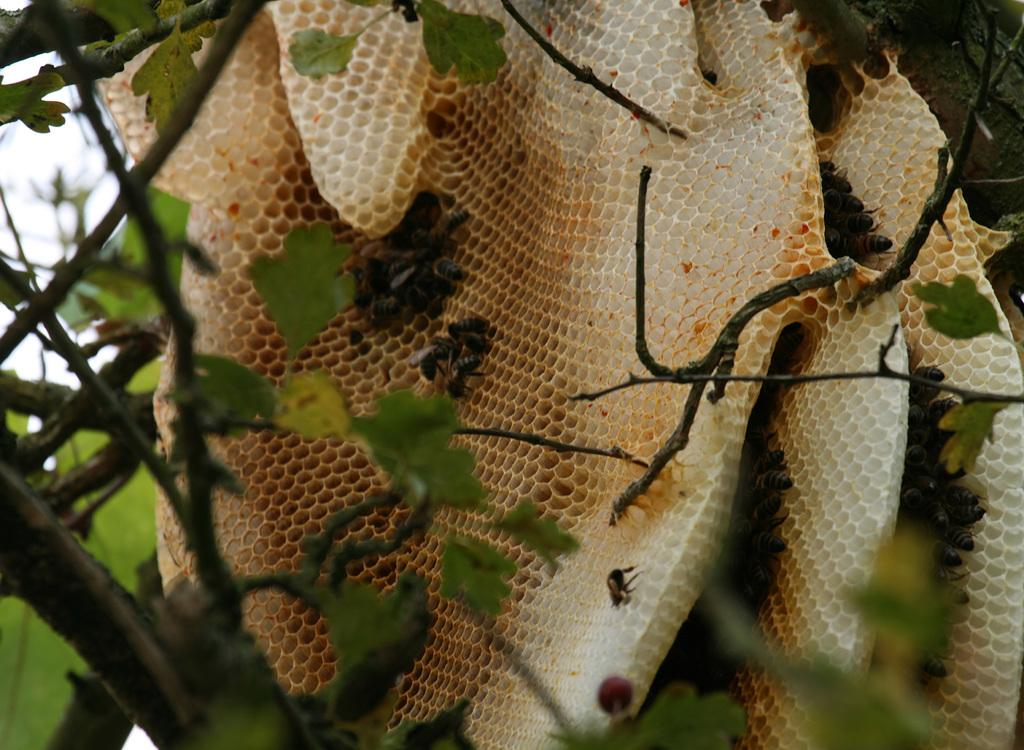What type of structures can be seen in the image? There are beehives in the image. What natural elements are present in the image? There are trees in the image. What type of insects can be seen in the image? Honey bees are present in the image. What type of calendar can be seen hanging from the tree in the image? There is no calendar present in the image; it features beehives, trees, and honey bees. What ghostly figures are visible among the beehives in the image? There are no ghosts or ghostly figures visible in the image. 